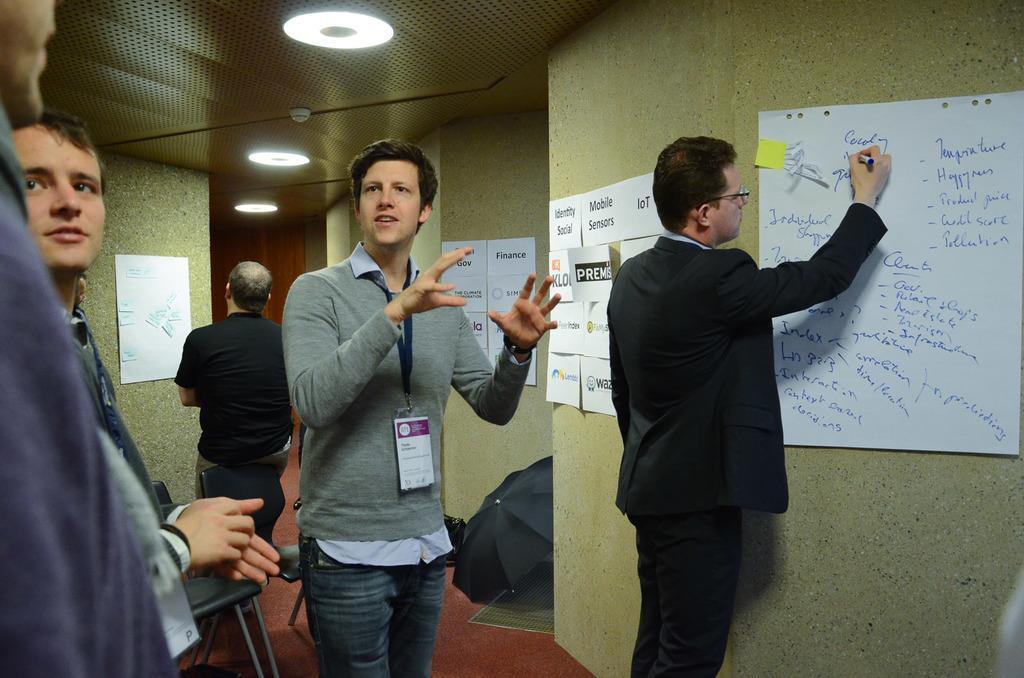Please provide a concise description of this image. This is the picture of a room. On the right side of the image there is a person standing and writing. In the middle of the image there is a person standing and talking. On the left side of the image there are three persons standing. There are posters on the wall. At the top there are lights. At the bottom there are chairs and there is an umbrella and there is a mat. 